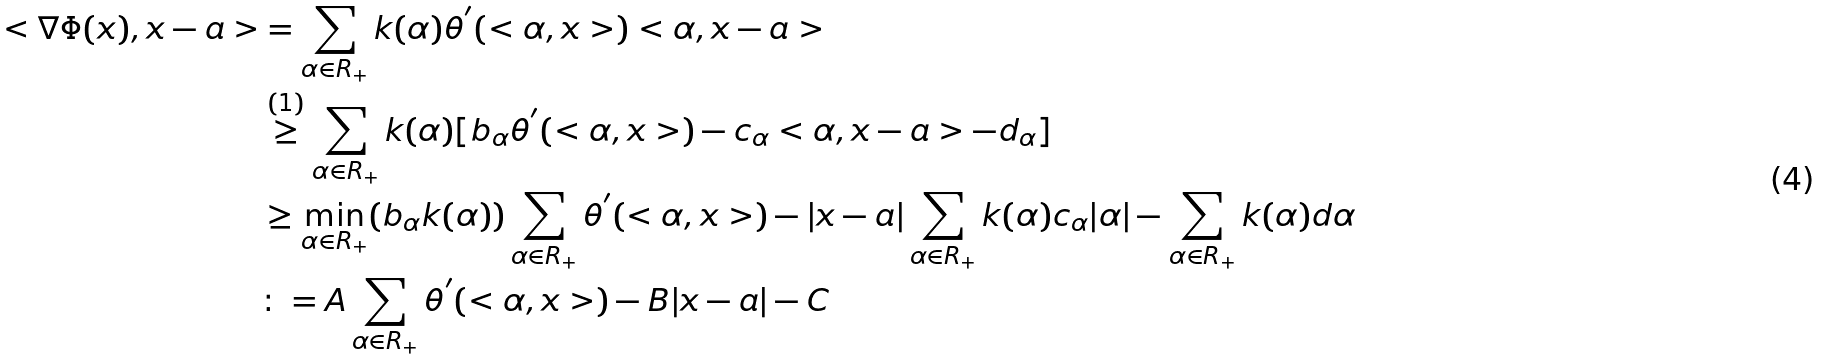Convert formula to latex. <formula><loc_0><loc_0><loc_500><loc_500>< \nabla \Phi ( x ) , x - a > & = \sum _ { \alpha \in R _ { + } } k ( \alpha ) \theta ^ { ^ { \prime } } ( < \alpha , x > ) < \alpha , x - a > \\ & \overset { ( 1 ) } { \geq } \sum _ { \alpha \in R _ { + } } k ( \alpha ) [ b _ { \alpha } \theta ^ { ^ { \prime } } ( < \alpha , x > ) - c _ { \alpha } < \alpha , x - a > - d _ { \alpha } ] \\ & \geq \min _ { \alpha \in R _ { + } } ( b _ { \alpha } k ( \alpha ) ) \sum _ { \alpha \in R _ { + } } \theta ^ { ^ { \prime } } ( < \alpha , x > ) - | x - a | \sum _ { \alpha \in R _ { + } } k ( \alpha ) { c _ { \alpha } } | \alpha | - \sum _ { \alpha \in R _ { + } } k ( \alpha ) d { \alpha } \\ & \colon = A \sum _ { \alpha \in R _ { + } } \theta ^ { ^ { \prime } } ( < \alpha , x > ) - B | x - a | - C</formula> 